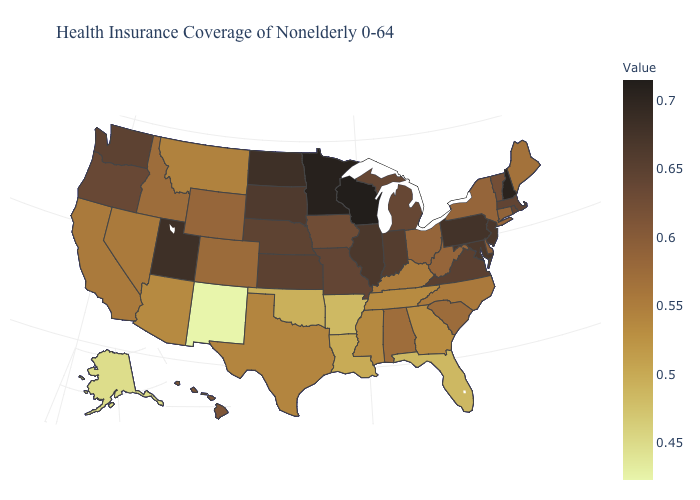Among the states that border South Dakota , does Minnesota have the highest value?
Short answer required. Yes. Which states have the lowest value in the USA?
Be succinct. New Mexico. Which states have the highest value in the USA?
Write a very short answer. Wisconsin. Among the states that border Florida , does Alabama have the lowest value?
Quick response, please. No. Does Illinois have a higher value than Minnesota?
Write a very short answer. No. 